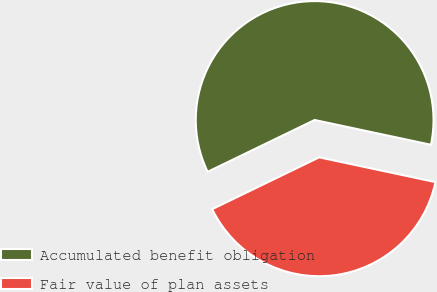<chart> <loc_0><loc_0><loc_500><loc_500><pie_chart><fcel>Accumulated benefit obligation<fcel>Fair value of plan assets<nl><fcel>60.52%<fcel>39.48%<nl></chart> 